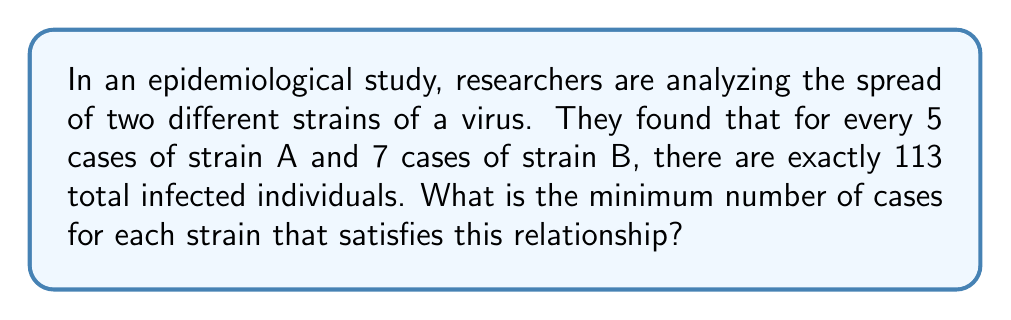Can you answer this question? To solve this problem, we need to use a linear Diophantine equation. Let's approach this step-by-step:

1) Let $x$ be the number of groups of 5 cases of strain A, and $y$ be the number of groups of 7 cases of strain B. We can write the equation:

   $$5x + 7y = 113$$

2) This is a linear Diophantine equation. To find integer solutions, we first need to check if the greatest common divisor (GCD) of the coefficients (5 and 7) divides the constant term (113).

3) $GCD(5,7) = 1$, which divides 113. So, integer solutions exist.

4) We can use the extended Euclidean algorithm to find a particular solution:

   $$7 = 1 \cdot 5 + 2$$
   $$5 = 2 \cdot 2 + 1$$
   $$2 = 2 \cdot 1 + 0$$

   Working backwards:
   $$1 = 5 - 2 \cdot 2 = 5 - 2 \cdot (7 - 1 \cdot 5) = 3 \cdot 5 - 2 \cdot 7$$

5) Multiply both sides by 113:

   $$113 = 339 \cdot 5 - 226 \cdot 7$$

6) So, a particular solution is $x_0 = 339, y_0 = -226$.

7) The general solution is:

   $$x = 339 + 7t$$
   $$y = -226 - 5t$$

   where $t$ is an integer.

8) To find the minimum positive solution, we need to find the smallest non-negative $t$ that makes both $x$ and $y$ positive:

   For $x$: $339 + 7t \geq 0$ is always true for $t \geq 0$
   For $y$: $-226 - 5t \geq 0$
            $-5t \geq 226$
            $t \leq -45.2$

   The smallest integer $t$ that satisfies both is $t = -46$

9) Substituting $t = -46$:

   $x = 339 + 7(-46) = 17$
   $y = -226 - 5(-46) = 4$

10) Therefore, the minimum solution is 17 groups of 5 cases of strain A (85 cases) and 4 groups of 7 cases of strain B (28 cases).
Answer: 85 cases of strain A, 28 cases of strain B 